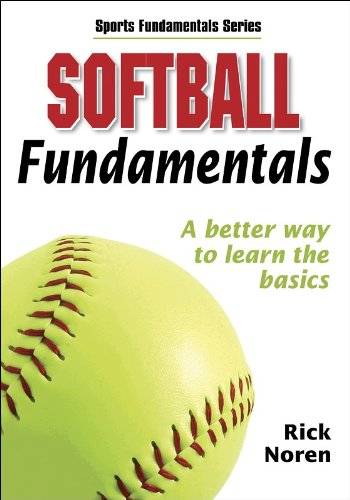What is the genre of this book? This book belongs to the 'Sports & Outdoors' genre, focusing specifically on softball training and fundamentals. 